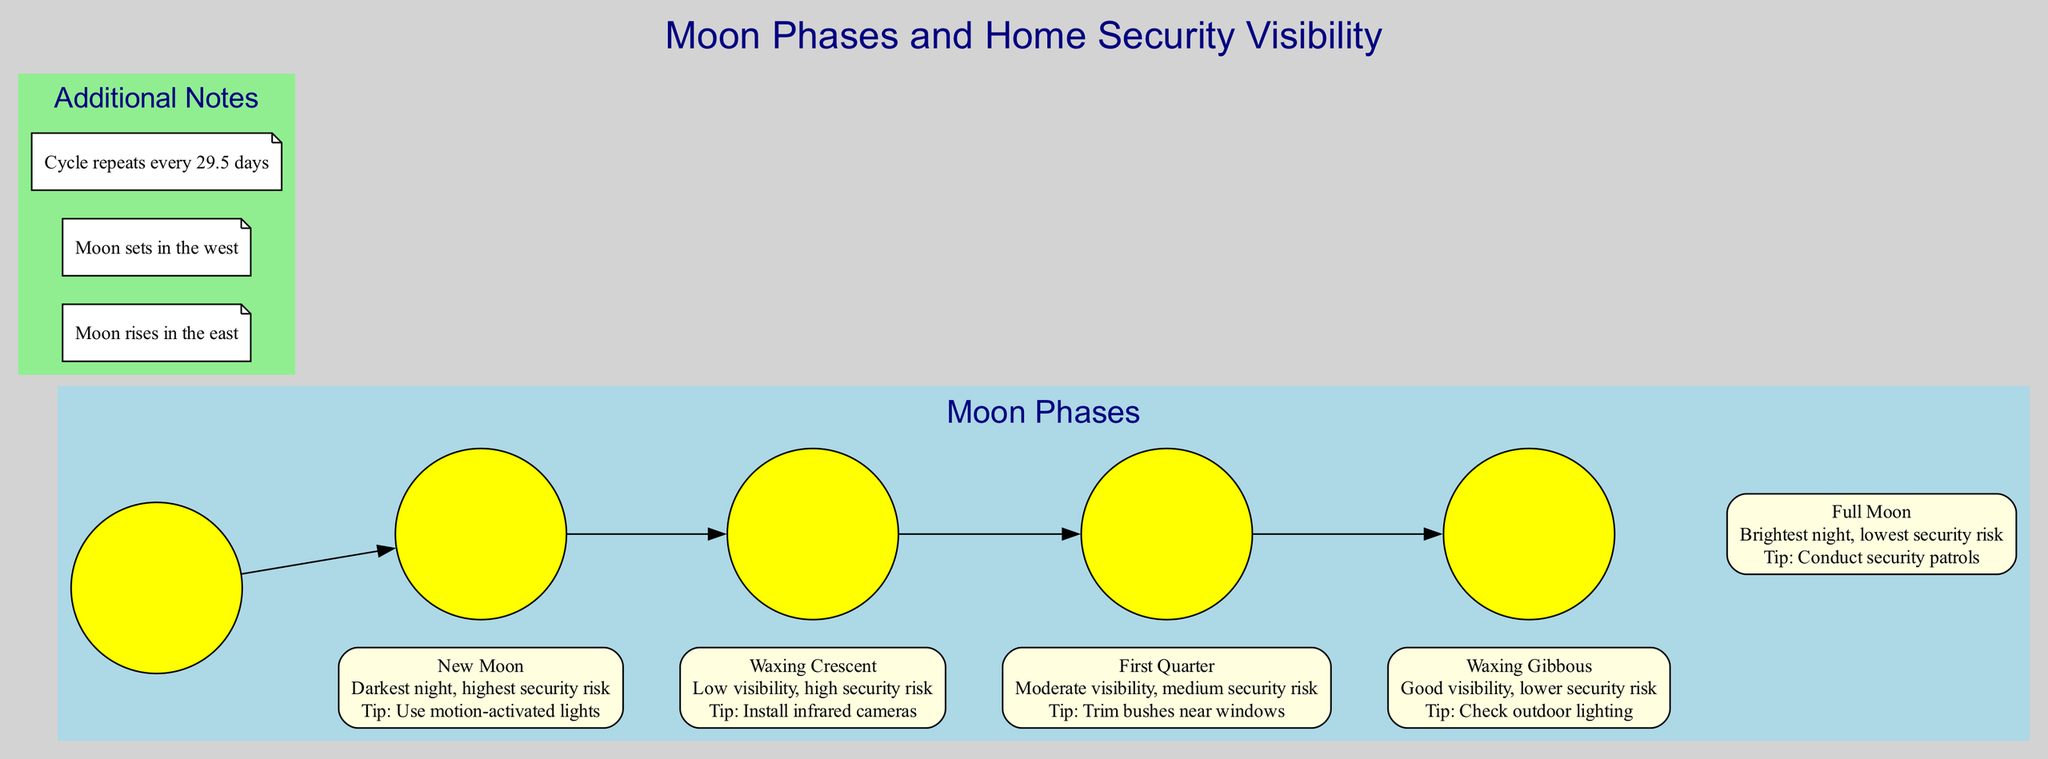What is the visibility during a New Moon? The diagram states that during a New Moon, the visibility is described as "Darkest night."
Answer: Darkest night What security tip is associated with the Waxing Crescent phase? According to the diagram, the security tip for the Waxing Crescent phase is to "Install infrared cameras."
Answer: Install infrared cameras How many moon phases are illustrated in the diagram? The diagram highlights a total of 5 moon phases: New Moon, Waxing Crescent, First Quarter, Waxing Gibbous, and Full Moon.
Answer: 5 Which moon phase offers the lowest security risk? Based on the diagram, the Full Moon is indicated as having the "lowest security risk."
Answer: Full Moon What is the recommended security action during the Full Moon? The diagram advises to "Conduct security patrols" during the Full Moon.
Answer: Conduct security patrols Which moon phase has "Good visibility" and what security tip is recommended? The Waxing Gibbous phase is noted for "Good visibility," and the advised security tip is to "Check outdoor lighting."
Answer: Check outdoor lighting What happens to the moon visibility as it transitions from New Moon to Full Moon? As the moon transitions from New Moon to Full Moon, the visibility increases from "Darkest night" to "Brightest night." This means the risk decreases as well.
Answer: Increases What cycle duration is indicated for the moon phases? The additional notes state that the moon cycle "repeats every 29.5 days."
Answer: 29.5 days 